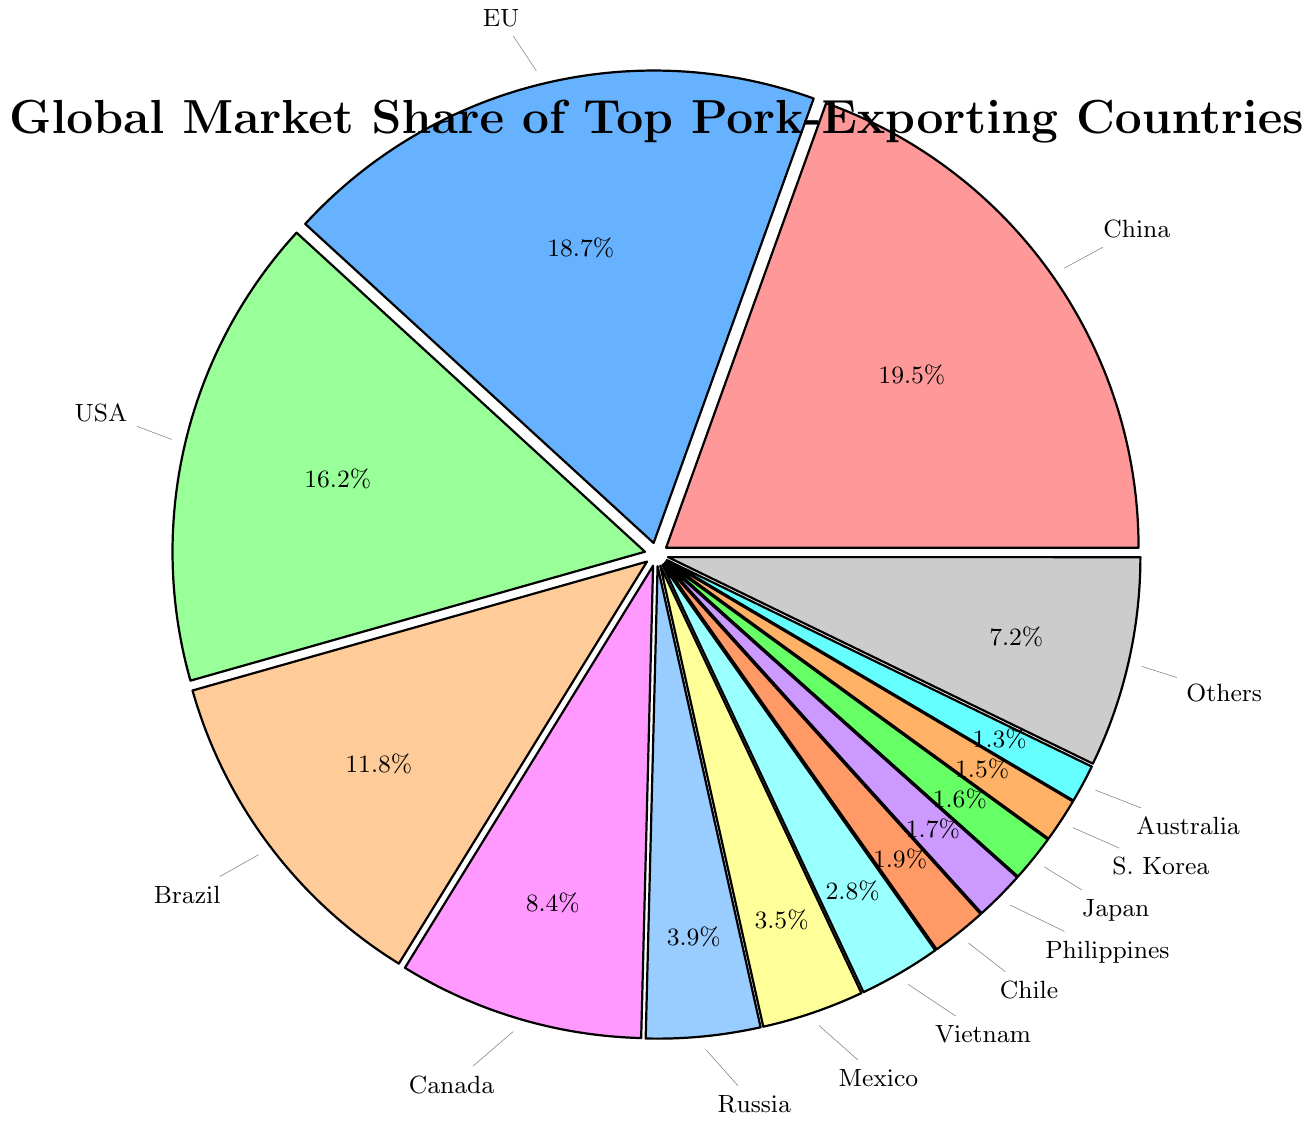What is the total market share of the top three pork-exporting countries? The top three pork-exporting countries are China, the European Union, and the United States. Their market shares are 19.5%, 18.7%, and 16.2%, respectively. Adding these values gives 19.5 + 18.7 + 16.2 = 54.4%.
Answer: 54.4% Which country has a larger market share, Brazil or Canada? The market share of Brazil is 11.8%, while that of Canada is 8.4%. Since 11.8% is greater than 8.4%, Brazil has a larger market share than Canada.
Answer: Brazil How much more market share does China have compared to the European Union? China's market share is 19.5%, and the European Union's market share is 18.7%. Subtracting these values gives 19.5 - 18.7 = 0.8%.
Answer: 0.8% What is the combined market share of Russia, Mexico, and Vietnam? The market shares of Russia, Mexico, and Vietnam are 3.9%, 3.5%, and 2.8%, respectively. Adding these values gives 3.9 + 3.5 + 2.8 = 10.2%.
Answer: 10.2% Which two countries have the smallest market shares, and what are those shares? The two countries with the smallest market shares are Australia with 1.3% and South Korea with 1.5%.
Answer: Australia, South Korea What is the average market share of the European Union, United States, and Brazil? The market shares of the European Union, United States, and Brazil are 18.7%, 16.2%, and 11.8%, respectively. Adding these values gives 18.7 + 16.2 + 11.8 = 46.7%. Dividing by 3 gives 46.7 / 3 = 15.57%.
Answer: 15.57% Which region is denoted by the yellow segment? The yellow segment represents Canada, as evident from the chart.
Answer: Canada What percentage of the market share is held by countries not listed individually (Others)? The "Others" category has a market share of 7.2%. No computation is necessary as the information is directly taken from the chart.
Answer: 7.2% How many countries have a market share greater than 10%? The countries with a market share greater than 10% are China, the European Union, the United States, and Brazil. Therefore, there are 4 such countries.
Answer: 4 By how much does the market share of the United States exceed that of Canada? The market share of the United States is 16.2%, and Canada's is 8.4%. Subtracting these values gives 16.2 - 8.4 = 7.8%.
Answer: 7.8% 